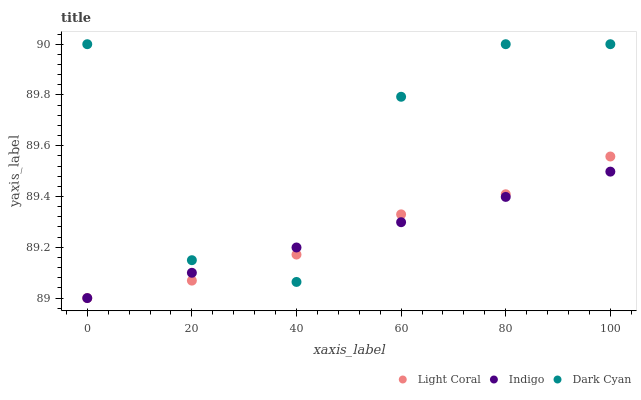Does Indigo have the minimum area under the curve?
Answer yes or no. Yes. Does Dark Cyan have the maximum area under the curve?
Answer yes or no. Yes. Does Dark Cyan have the minimum area under the curve?
Answer yes or no. No. Does Indigo have the maximum area under the curve?
Answer yes or no. No. Is Indigo the smoothest?
Answer yes or no. Yes. Is Dark Cyan the roughest?
Answer yes or no. Yes. Is Dark Cyan the smoothest?
Answer yes or no. No. Is Indigo the roughest?
Answer yes or no. No. Does Light Coral have the lowest value?
Answer yes or no. Yes. Does Dark Cyan have the lowest value?
Answer yes or no. No. Does Dark Cyan have the highest value?
Answer yes or no. Yes. Does Indigo have the highest value?
Answer yes or no. No. Does Indigo intersect Dark Cyan?
Answer yes or no. Yes. Is Indigo less than Dark Cyan?
Answer yes or no. No. Is Indigo greater than Dark Cyan?
Answer yes or no. No. 